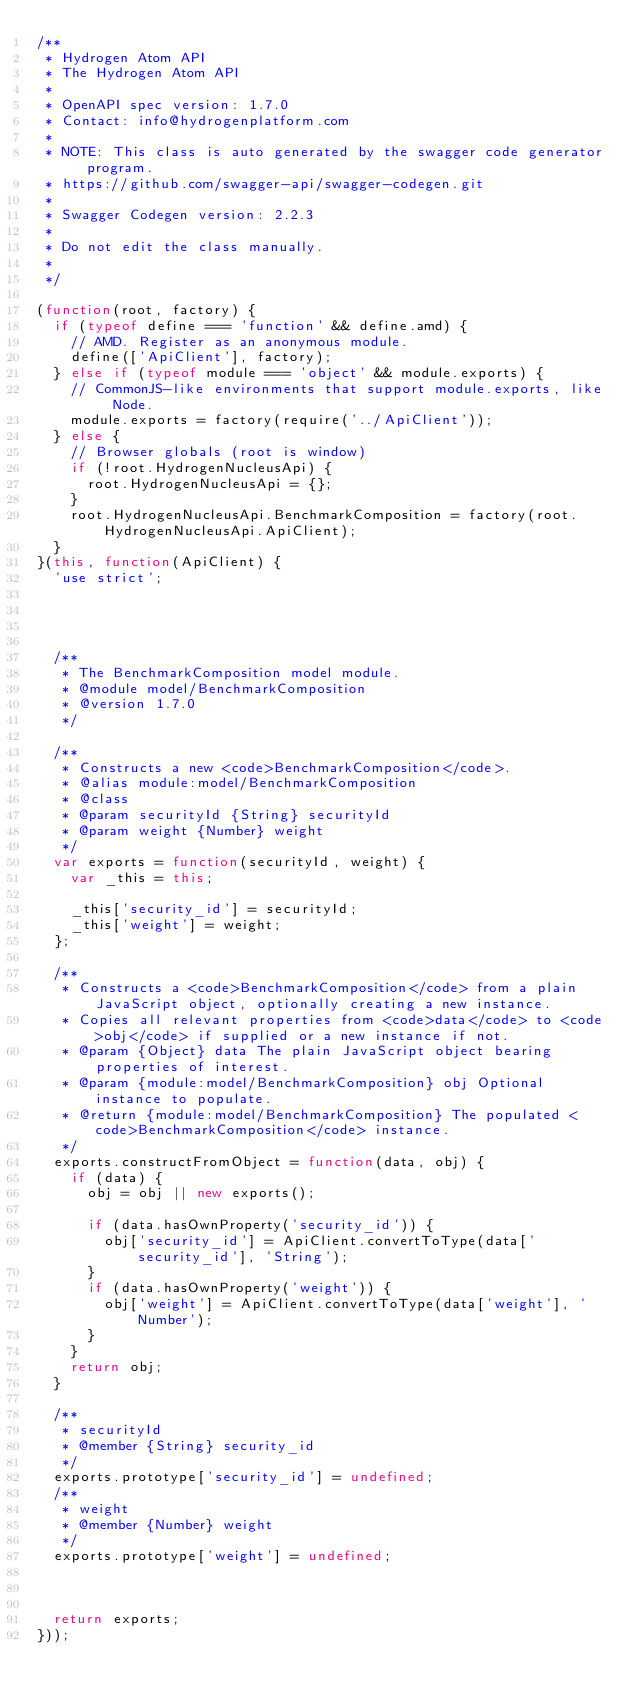<code> <loc_0><loc_0><loc_500><loc_500><_JavaScript_>/**
 * Hydrogen Atom API
 * The Hydrogen Atom API
 *
 * OpenAPI spec version: 1.7.0
 * Contact: info@hydrogenplatform.com
 *
 * NOTE: This class is auto generated by the swagger code generator program.
 * https://github.com/swagger-api/swagger-codegen.git
 *
 * Swagger Codegen version: 2.2.3
 *
 * Do not edit the class manually.
 *
 */

(function(root, factory) {
  if (typeof define === 'function' && define.amd) {
    // AMD. Register as an anonymous module.
    define(['ApiClient'], factory);
  } else if (typeof module === 'object' && module.exports) {
    // CommonJS-like environments that support module.exports, like Node.
    module.exports = factory(require('../ApiClient'));
  } else {
    // Browser globals (root is window)
    if (!root.HydrogenNucleusApi) {
      root.HydrogenNucleusApi = {};
    }
    root.HydrogenNucleusApi.BenchmarkComposition = factory(root.HydrogenNucleusApi.ApiClient);
  }
}(this, function(ApiClient) {
  'use strict';




  /**
   * The BenchmarkComposition model module.
   * @module model/BenchmarkComposition
   * @version 1.7.0
   */

  /**
   * Constructs a new <code>BenchmarkComposition</code>.
   * @alias module:model/BenchmarkComposition
   * @class
   * @param securityId {String} securityId
   * @param weight {Number} weight
   */
  var exports = function(securityId, weight) {
    var _this = this;

    _this['security_id'] = securityId;
    _this['weight'] = weight;
  };

  /**
   * Constructs a <code>BenchmarkComposition</code> from a plain JavaScript object, optionally creating a new instance.
   * Copies all relevant properties from <code>data</code> to <code>obj</code> if supplied or a new instance if not.
   * @param {Object} data The plain JavaScript object bearing properties of interest.
   * @param {module:model/BenchmarkComposition} obj Optional instance to populate.
   * @return {module:model/BenchmarkComposition} The populated <code>BenchmarkComposition</code> instance.
   */
  exports.constructFromObject = function(data, obj) {
    if (data) {
      obj = obj || new exports();

      if (data.hasOwnProperty('security_id')) {
        obj['security_id'] = ApiClient.convertToType(data['security_id'], 'String');
      }
      if (data.hasOwnProperty('weight')) {
        obj['weight'] = ApiClient.convertToType(data['weight'], 'Number');
      }
    }
    return obj;
  }

  /**
   * securityId
   * @member {String} security_id
   */
  exports.prototype['security_id'] = undefined;
  /**
   * weight
   * @member {Number} weight
   */
  exports.prototype['weight'] = undefined;



  return exports;
}));


</code> 